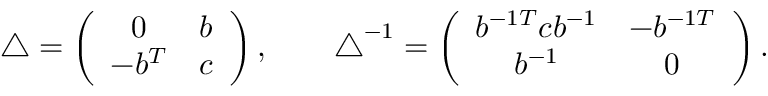<formula> <loc_0><loc_0><loc_500><loc_500>\begin{array} { r } { \triangle = \left ( \begin{array} { c c } { 0 } & { b } \\ { - b ^ { T } } & { c } \end{array} \right ) , \quad \triangle ^ { - 1 } = \left ( \begin{array} { c c } { b ^ { - 1 T } c b ^ { - 1 } } & { - b ^ { - 1 T } } \\ { b ^ { - 1 } } & { 0 } \end{array} \right ) . } \end{array}</formula> 